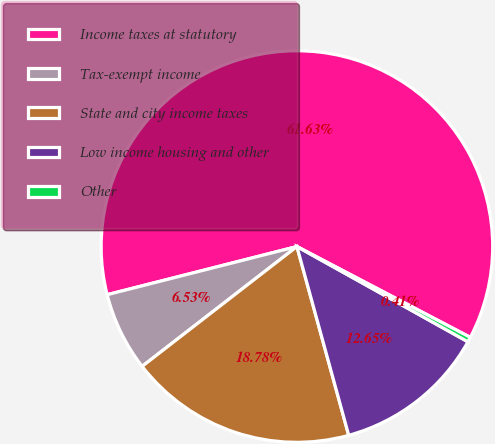<chart> <loc_0><loc_0><loc_500><loc_500><pie_chart><fcel>Income taxes at statutory<fcel>Tax-exempt income<fcel>State and city income taxes<fcel>Low income housing and other<fcel>Other<nl><fcel>61.64%<fcel>6.53%<fcel>18.78%<fcel>12.65%<fcel>0.41%<nl></chart> 